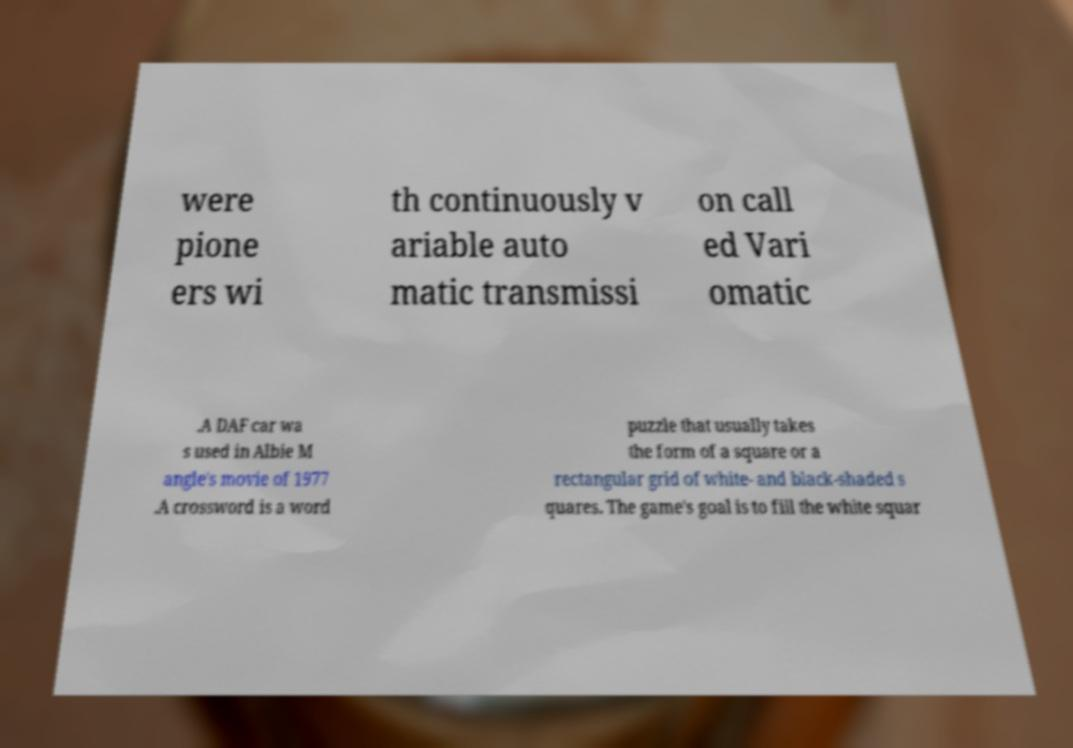Could you assist in decoding the text presented in this image and type it out clearly? were pione ers wi th continuously v ariable auto matic transmissi on call ed Vari omatic .A DAF car wa s used in Albie M angle's movie of 1977 .A crossword is a word puzzle that usually takes the form of a square or a rectangular grid of white- and black-shaded s quares. The game's goal is to fill the white squar 